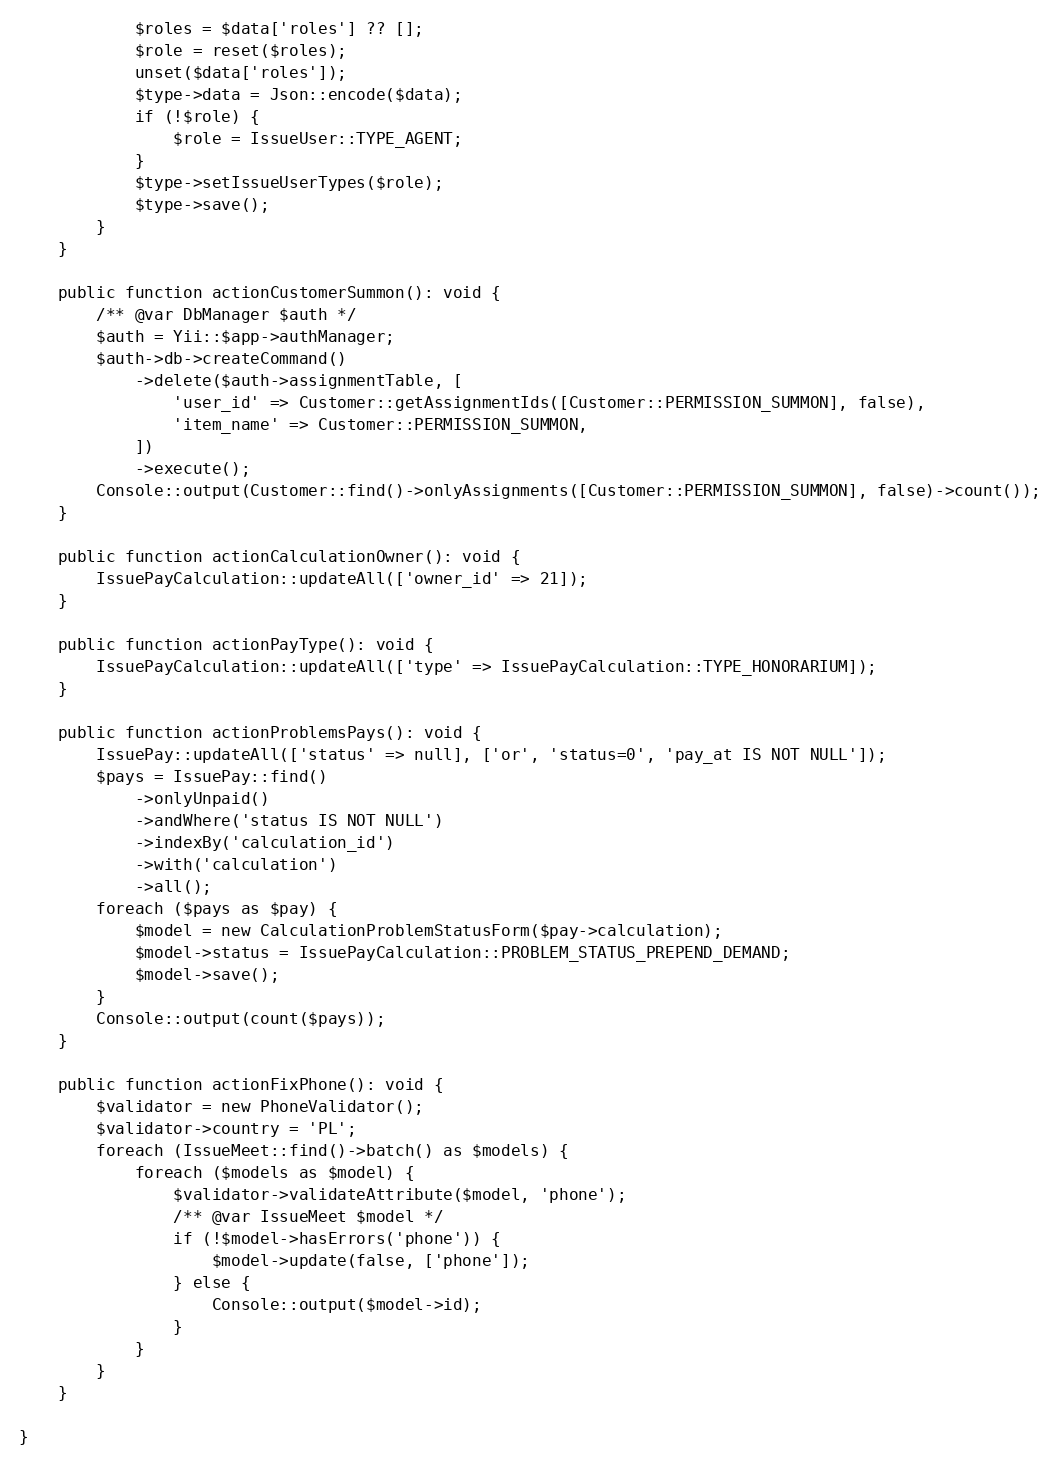Convert code to text. <code><loc_0><loc_0><loc_500><loc_500><_PHP_>			$roles = $data['roles'] ?? [];
			$role = reset($roles);
			unset($data['roles']);
			$type->data = Json::encode($data);
			if (!$role) {
				$role = IssueUser::TYPE_AGENT;
			}
			$type->setIssueUserTypes($role);
			$type->save();
		}
	}

	public function actionCustomerSummon(): void {
		/** @var DbManager $auth */
		$auth = Yii::$app->authManager;
		$auth->db->createCommand()
			->delete($auth->assignmentTable, [
				'user_id' => Customer::getAssignmentIds([Customer::PERMISSION_SUMMON], false),
				'item_name' => Customer::PERMISSION_SUMMON,
			])
			->execute();
		Console::output(Customer::find()->onlyAssignments([Customer::PERMISSION_SUMMON], false)->count());
	}

	public function actionCalculationOwner(): void {
		IssuePayCalculation::updateAll(['owner_id' => 21]);
	}

	public function actionPayType(): void {
		IssuePayCalculation::updateAll(['type' => IssuePayCalculation::TYPE_HONORARIUM]);
	}

	public function actionProblemsPays(): void {
		IssuePay::updateAll(['status' => null], ['or', 'status=0', 'pay_at IS NOT NULL']);
		$pays = IssuePay::find()
			->onlyUnpaid()
			->andWhere('status IS NOT NULL')
			->indexBy('calculation_id')
			->with('calculation')
			->all();
		foreach ($pays as $pay) {
			$model = new CalculationProblemStatusForm($pay->calculation);
			$model->status = IssuePayCalculation::PROBLEM_STATUS_PREPEND_DEMAND;
			$model->save();
		}
		Console::output(count($pays));
	}

	public function actionFixPhone(): void {
		$validator = new PhoneValidator();
		$validator->country = 'PL';
		foreach (IssueMeet::find()->batch() as $models) {
			foreach ($models as $model) {
				$validator->validateAttribute($model, 'phone');
				/** @var IssueMeet $model */
				if (!$model->hasErrors('phone')) {
					$model->update(false, ['phone']);
				} else {
					Console::output($model->id);
				}
			}
		}
	}

}
</code> 